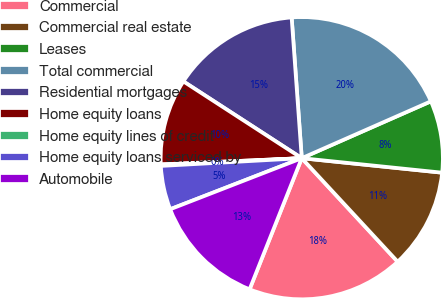<chart> <loc_0><loc_0><loc_500><loc_500><pie_chart><fcel>Commercial<fcel>Commercial real estate<fcel>Leases<fcel>Total commercial<fcel>Residential mortgages<fcel>Home equity loans<fcel>Home equity lines of credit<fcel>Home equity loans serviced by<fcel>Automobile<nl><fcel>17.92%<fcel>11.47%<fcel>8.24%<fcel>19.54%<fcel>14.7%<fcel>9.86%<fcel>0.17%<fcel>5.02%<fcel>13.08%<nl></chart> 